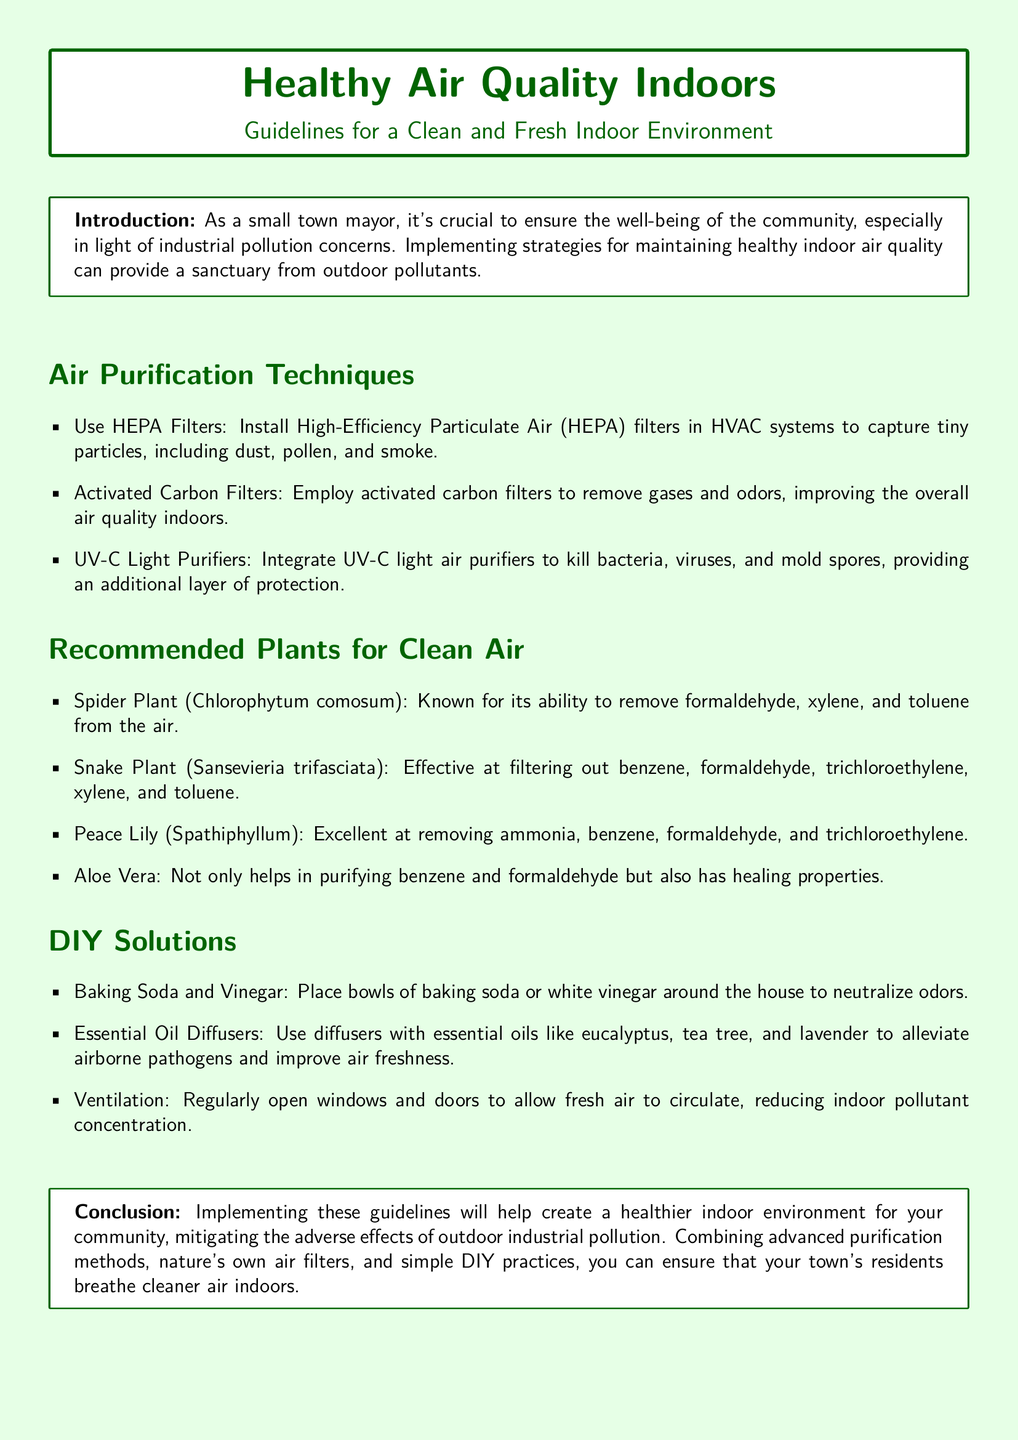What is the title of the document? The title is prominently displayed at the center of the document.
Answer: Healthy Air Quality Indoors What is the first air purification technique mentioned? The first technique is listed under "Air Purification Techniques" in a clear bullet point.
Answer: Use HEPA Filters Which plant is known for removing ammonia? The specific plant is listed under "Recommended Plants for Clean Air".
Answer: Peace Lily What DIY solution can neutralize odors? This specific solution is mentioned in the "DIY Solutions" section.
Answer: Baking Soda and Vinegar What type of filtration is effective against tiny particles? This term is introduced as a key air purification method.
Answer: HEPA Filters How many recommended plants for clean air are listed? The number of items in the "Recommended Plants for Clean Air" section indicates the total.
Answer: Four Which essential oil is suggested to improve air freshness? The essential oil is specifically named in the "DIY Solutions" section.
Answer: Eucalyptus What is the main goal of implementing these guidelines? This goal is stated in the conclusion of the document.
Answer: Healthier indoor environment What can be integrated to kill bacteria in the air? This item is described under "Air Purification Techniques".
Answer: UV-C Light Purifiers 